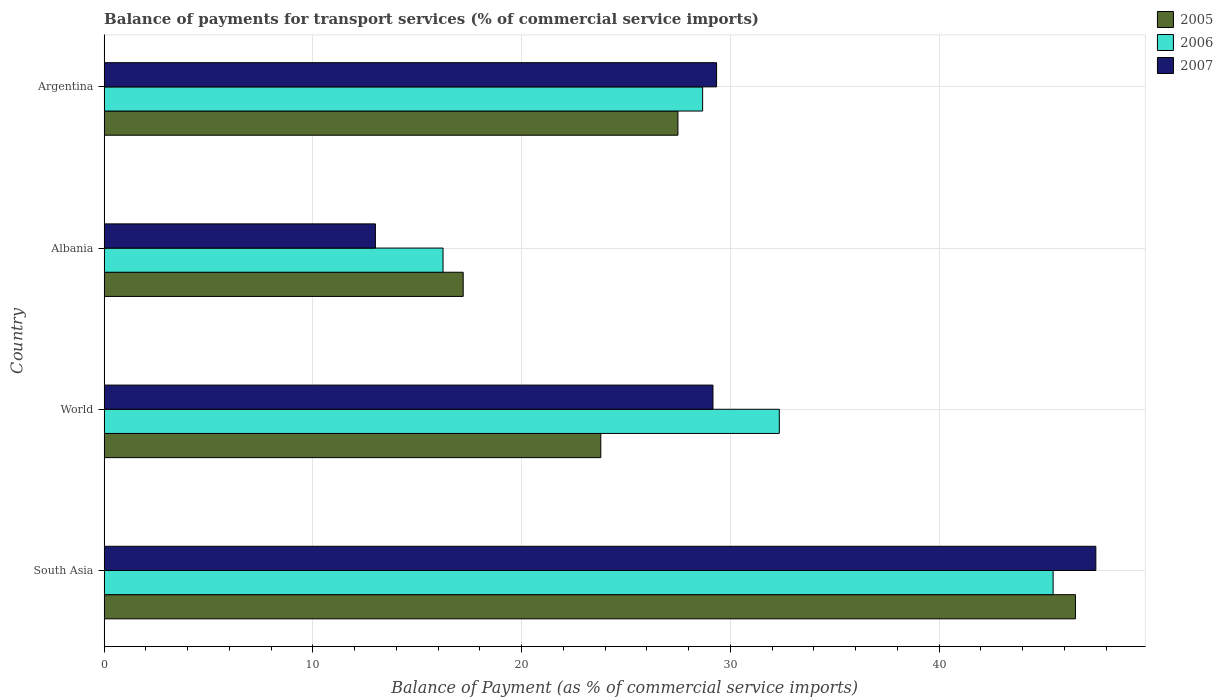How many groups of bars are there?
Your answer should be compact. 4. How many bars are there on the 1st tick from the top?
Offer a very short reply. 3. What is the balance of payments for transport services in 2007 in Argentina?
Offer a terse response. 29.34. Across all countries, what is the maximum balance of payments for transport services in 2007?
Make the answer very short. 47.5. Across all countries, what is the minimum balance of payments for transport services in 2005?
Your response must be concise. 17.2. In which country was the balance of payments for transport services in 2007 minimum?
Your answer should be very brief. Albania. What is the total balance of payments for transport services in 2007 in the graph?
Provide a succinct answer. 118.99. What is the difference between the balance of payments for transport services in 2007 in Argentina and that in World?
Offer a very short reply. 0.17. What is the difference between the balance of payments for transport services in 2006 in Argentina and the balance of payments for transport services in 2005 in World?
Your response must be concise. 4.88. What is the average balance of payments for transport services in 2006 per country?
Your answer should be compact. 30.67. What is the difference between the balance of payments for transport services in 2005 and balance of payments for transport services in 2006 in World?
Provide a succinct answer. -8.55. In how many countries, is the balance of payments for transport services in 2006 greater than 42 %?
Make the answer very short. 1. What is the ratio of the balance of payments for transport services in 2007 in Albania to that in World?
Your answer should be very brief. 0.45. Is the balance of payments for transport services in 2007 in Albania less than that in Argentina?
Make the answer very short. Yes. Is the difference between the balance of payments for transport services in 2005 in Albania and South Asia greater than the difference between the balance of payments for transport services in 2006 in Albania and South Asia?
Offer a terse response. No. What is the difference between the highest and the second highest balance of payments for transport services in 2007?
Ensure brevity in your answer.  18.17. What is the difference between the highest and the lowest balance of payments for transport services in 2006?
Your answer should be compact. 29.22. What does the 2nd bar from the top in World represents?
Offer a very short reply. 2006. Is it the case that in every country, the sum of the balance of payments for transport services in 2007 and balance of payments for transport services in 2005 is greater than the balance of payments for transport services in 2006?
Provide a short and direct response. Yes. How many countries are there in the graph?
Give a very brief answer. 4. Are the values on the major ticks of X-axis written in scientific E-notation?
Make the answer very short. No. Does the graph contain grids?
Provide a short and direct response. Yes. How many legend labels are there?
Offer a terse response. 3. How are the legend labels stacked?
Ensure brevity in your answer.  Vertical. What is the title of the graph?
Provide a succinct answer. Balance of payments for transport services (% of commercial service imports). What is the label or title of the X-axis?
Ensure brevity in your answer.  Balance of Payment (as % of commercial service imports). What is the label or title of the Y-axis?
Make the answer very short. Country. What is the Balance of Payment (as % of commercial service imports) of 2005 in South Asia?
Offer a terse response. 46.53. What is the Balance of Payment (as % of commercial service imports) of 2006 in South Asia?
Give a very brief answer. 45.46. What is the Balance of Payment (as % of commercial service imports) of 2007 in South Asia?
Give a very brief answer. 47.5. What is the Balance of Payment (as % of commercial service imports) of 2005 in World?
Ensure brevity in your answer.  23.79. What is the Balance of Payment (as % of commercial service imports) in 2006 in World?
Make the answer very short. 32.34. What is the Balance of Payment (as % of commercial service imports) in 2007 in World?
Offer a very short reply. 29.16. What is the Balance of Payment (as % of commercial service imports) of 2005 in Albania?
Your answer should be compact. 17.2. What is the Balance of Payment (as % of commercial service imports) of 2006 in Albania?
Make the answer very short. 16.23. What is the Balance of Payment (as % of commercial service imports) in 2007 in Albania?
Ensure brevity in your answer.  12.99. What is the Balance of Payment (as % of commercial service imports) in 2005 in Argentina?
Offer a terse response. 27.48. What is the Balance of Payment (as % of commercial service imports) in 2006 in Argentina?
Provide a succinct answer. 28.67. What is the Balance of Payment (as % of commercial service imports) of 2007 in Argentina?
Provide a short and direct response. 29.34. Across all countries, what is the maximum Balance of Payment (as % of commercial service imports) in 2005?
Keep it short and to the point. 46.53. Across all countries, what is the maximum Balance of Payment (as % of commercial service imports) of 2006?
Ensure brevity in your answer.  45.46. Across all countries, what is the maximum Balance of Payment (as % of commercial service imports) of 2007?
Keep it short and to the point. 47.5. Across all countries, what is the minimum Balance of Payment (as % of commercial service imports) in 2005?
Your answer should be very brief. 17.2. Across all countries, what is the minimum Balance of Payment (as % of commercial service imports) in 2006?
Provide a succinct answer. 16.23. Across all countries, what is the minimum Balance of Payment (as % of commercial service imports) of 2007?
Keep it short and to the point. 12.99. What is the total Balance of Payment (as % of commercial service imports) of 2005 in the graph?
Your answer should be compact. 115. What is the total Balance of Payment (as % of commercial service imports) of 2006 in the graph?
Ensure brevity in your answer.  122.69. What is the total Balance of Payment (as % of commercial service imports) in 2007 in the graph?
Offer a terse response. 118.99. What is the difference between the Balance of Payment (as % of commercial service imports) in 2005 in South Asia and that in World?
Your answer should be compact. 22.74. What is the difference between the Balance of Payment (as % of commercial service imports) of 2006 in South Asia and that in World?
Offer a terse response. 13.12. What is the difference between the Balance of Payment (as % of commercial service imports) in 2007 in South Asia and that in World?
Provide a succinct answer. 18.34. What is the difference between the Balance of Payment (as % of commercial service imports) of 2005 in South Asia and that in Albania?
Offer a terse response. 29.33. What is the difference between the Balance of Payment (as % of commercial service imports) in 2006 in South Asia and that in Albania?
Offer a very short reply. 29.22. What is the difference between the Balance of Payment (as % of commercial service imports) in 2007 in South Asia and that in Albania?
Offer a very short reply. 34.51. What is the difference between the Balance of Payment (as % of commercial service imports) in 2005 in South Asia and that in Argentina?
Provide a succinct answer. 19.04. What is the difference between the Balance of Payment (as % of commercial service imports) in 2006 in South Asia and that in Argentina?
Offer a terse response. 16.79. What is the difference between the Balance of Payment (as % of commercial service imports) of 2007 in South Asia and that in Argentina?
Your response must be concise. 18.17. What is the difference between the Balance of Payment (as % of commercial service imports) in 2005 in World and that in Albania?
Provide a short and direct response. 6.59. What is the difference between the Balance of Payment (as % of commercial service imports) in 2006 in World and that in Albania?
Your answer should be compact. 16.11. What is the difference between the Balance of Payment (as % of commercial service imports) of 2007 in World and that in Albania?
Your answer should be very brief. 16.17. What is the difference between the Balance of Payment (as % of commercial service imports) in 2005 in World and that in Argentina?
Your answer should be very brief. -3.69. What is the difference between the Balance of Payment (as % of commercial service imports) in 2006 in World and that in Argentina?
Offer a terse response. 3.67. What is the difference between the Balance of Payment (as % of commercial service imports) in 2007 in World and that in Argentina?
Keep it short and to the point. -0.17. What is the difference between the Balance of Payment (as % of commercial service imports) of 2005 in Albania and that in Argentina?
Make the answer very short. -10.29. What is the difference between the Balance of Payment (as % of commercial service imports) in 2006 in Albania and that in Argentina?
Provide a short and direct response. -12.43. What is the difference between the Balance of Payment (as % of commercial service imports) of 2007 in Albania and that in Argentina?
Give a very brief answer. -16.34. What is the difference between the Balance of Payment (as % of commercial service imports) of 2005 in South Asia and the Balance of Payment (as % of commercial service imports) of 2006 in World?
Ensure brevity in your answer.  14.19. What is the difference between the Balance of Payment (as % of commercial service imports) of 2005 in South Asia and the Balance of Payment (as % of commercial service imports) of 2007 in World?
Ensure brevity in your answer.  17.36. What is the difference between the Balance of Payment (as % of commercial service imports) of 2006 in South Asia and the Balance of Payment (as % of commercial service imports) of 2007 in World?
Give a very brief answer. 16.29. What is the difference between the Balance of Payment (as % of commercial service imports) of 2005 in South Asia and the Balance of Payment (as % of commercial service imports) of 2006 in Albania?
Keep it short and to the point. 30.29. What is the difference between the Balance of Payment (as % of commercial service imports) of 2005 in South Asia and the Balance of Payment (as % of commercial service imports) of 2007 in Albania?
Provide a short and direct response. 33.53. What is the difference between the Balance of Payment (as % of commercial service imports) of 2006 in South Asia and the Balance of Payment (as % of commercial service imports) of 2007 in Albania?
Offer a very short reply. 32.46. What is the difference between the Balance of Payment (as % of commercial service imports) in 2005 in South Asia and the Balance of Payment (as % of commercial service imports) in 2006 in Argentina?
Offer a very short reply. 17.86. What is the difference between the Balance of Payment (as % of commercial service imports) in 2005 in South Asia and the Balance of Payment (as % of commercial service imports) in 2007 in Argentina?
Ensure brevity in your answer.  17.19. What is the difference between the Balance of Payment (as % of commercial service imports) in 2006 in South Asia and the Balance of Payment (as % of commercial service imports) in 2007 in Argentina?
Provide a succinct answer. 16.12. What is the difference between the Balance of Payment (as % of commercial service imports) of 2005 in World and the Balance of Payment (as % of commercial service imports) of 2006 in Albania?
Your answer should be very brief. 7.56. What is the difference between the Balance of Payment (as % of commercial service imports) in 2005 in World and the Balance of Payment (as % of commercial service imports) in 2007 in Albania?
Provide a short and direct response. 10.8. What is the difference between the Balance of Payment (as % of commercial service imports) in 2006 in World and the Balance of Payment (as % of commercial service imports) in 2007 in Albania?
Provide a short and direct response. 19.35. What is the difference between the Balance of Payment (as % of commercial service imports) in 2005 in World and the Balance of Payment (as % of commercial service imports) in 2006 in Argentina?
Provide a short and direct response. -4.88. What is the difference between the Balance of Payment (as % of commercial service imports) of 2005 in World and the Balance of Payment (as % of commercial service imports) of 2007 in Argentina?
Provide a short and direct response. -5.55. What is the difference between the Balance of Payment (as % of commercial service imports) of 2006 in World and the Balance of Payment (as % of commercial service imports) of 2007 in Argentina?
Your response must be concise. 3. What is the difference between the Balance of Payment (as % of commercial service imports) in 2005 in Albania and the Balance of Payment (as % of commercial service imports) in 2006 in Argentina?
Keep it short and to the point. -11.47. What is the difference between the Balance of Payment (as % of commercial service imports) in 2005 in Albania and the Balance of Payment (as % of commercial service imports) in 2007 in Argentina?
Your answer should be very brief. -12.14. What is the difference between the Balance of Payment (as % of commercial service imports) of 2006 in Albania and the Balance of Payment (as % of commercial service imports) of 2007 in Argentina?
Offer a terse response. -13.1. What is the average Balance of Payment (as % of commercial service imports) in 2005 per country?
Make the answer very short. 28.75. What is the average Balance of Payment (as % of commercial service imports) in 2006 per country?
Your answer should be very brief. 30.67. What is the average Balance of Payment (as % of commercial service imports) of 2007 per country?
Offer a very short reply. 29.75. What is the difference between the Balance of Payment (as % of commercial service imports) of 2005 and Balance of Payment (as % of commercial service imports) of 2006 in South Asia?
Your response must be concise. 1.07. What is the difference between the Balance of Payment (as % of commercial service imports) in 2005 and Balance of Payment (as % of commercial service imports) in 2007 in South Asia?
Offer a very short reply. -0.98. What is the difference between the Balance of Payment (as % of commercial service imports) of 2006 and Balance of Payment (as % of commercial service imports) of 2007 in South Asia?
Your answer should be very brief. -2.05. What is the difference between the Balance of Payment (as % of commercial service imports) of 2005 and Balance of Payment (as % of commercial service imports) of 2006 in World?
Keep it short and to the point. -8.55. What is the difference between the Balance of Payment (as % of commercial service imports) in 2005 and Balance of Payment (as % of commercial service imports) in 2007 in World?
Offer a very short reply. -5.37. What is the difference between the Balance of Payment (as % of commercial service imports) of 2006 and Balance of Payment (as % of commercial service imports) of 2007 in World?
Provide a short and direct response. 3.18. What is the difference between the Balance of Payment (as % of commercial service imports) in 2005 and Balance of Payment (as % of commercial service imports) in 2006 in Albania?
Your answer should be compact. 0.97. What is the difference between the Balance of Payment (as % of commercial service imports) of 2005 and Balance of Payment (as % of commercial service imports) of 2007 in Albania?
Your answer should be compact. 4.2. What is the difference between the Balance of Payment (as % of commercial service imports) of 2006 and Balance of Payment (as % of commercial service imports) of 2007 in Albania?
Offer a terse response. 3.24. What is the difference between the Balance of Payment (as % of commercial service imports) in 2005 and Balance of Payment (as % of commercial service imports) in 2006 in Argentina?
Offer a terse response. -1.18. What is the difference between the Balance of Payment (as % of commercial service imports) of 2005 and Balance of Payment (as % of commercial service imports) of 2007 in Argentina?
Make the answer very short. -1.85. What is the difference between the Balance of Payment (as % of commercial service imports) of 2006 and Balance of Payment (as % of commercial service imports) of 2007 in Argentina?
Make the answer very short. -0.67. What is the ratio of the Balance of Payment (as % of commercial service imports) in 2005 in South Asia to that in World?
Provide a succinct answer. 1.96. What is the ratio of the Balance of Payment (as % of commercial service imports) in 2006 in South Asia to that in World?
Your response must be concise. 1.41. What is the ratio of the Balance of Payment (as % of commercial service imports) in 2007 in South Asia to that in World?
Make the answer very short. 1.63. What is the ratio of the Balance of Payment (as % of commercial service imports) of 2005 in South Asia to that in Albania?
Make the answer very short. 2.71. What is the ratio of the Balance of Payment (as % of commercial service imports) in 2006 in South Asia to that in Albania?
Provide a short and direct response. 2.8. What is the ratio of the Balance of Payment (as % of commercial service imports) of 2007 in South Asia to that in Albania?
Your response must be concise. 3.66. What is the ratio of the Balance of Payment (as % of commercial service imports) of 2005 in South Asia to that in Argentina?
Keep it short and to the point. 1.69. What is the ratio of the Balance of Payment (as % of commercial service imports) of 2006 in South Asia to that in Argentina?
Your response must be concise. 1.59. What is the ratio of the Balance of Payment (as % of commercial service imports) of 2007 in South Asia to that in Argentina?
Provide a short and direct response. 1.62. What is the ratio of the Balance of Payment (as % of commercial service imports) in 2005 in World to that in Albania?
Offer a very short reply. 1.38. What is the ratio of the Balance of Payment (as % of commercial service imports) in 2006 in World to that in Albania?
Your answer should be compact. 1.99. What is the ratio of the Balance of Payment (as % of commercial service imports) in 2007 in World to that in Albania?
Make the answer very short. 2.24. What is the ratio of the Balance of Payment (as % of commercial service imports) of 2005 in World to that in Argentina?
Provide a short and direct response. 0.87. What is the ratio of the Balance of Payment (as % of commercial service imports) of 2006 in World to that in Argentina?
Keep it short and to the point. 1.13. What is the ratio of the Balance of Payment (as % of commercial service imports) of 2007 in World to that in Argentina?
Give a very brief answer. 0.99. What is the ratio of the Balance of Payment (as % of commercial service imports) of 2005 in Albania to that in Argentina?
Your answer should be compact. 0.63. What is the ratio of the Balance of Payment (as % of commercial service imports) of 2006 in Albania to that in Argentina?
Make the answer very short. 0.57. What is the ratio of the Balance of Payment (as % of commercial service imports) of 2007 in Albania to that in Argentina?
Make the answer very short. 0.44. What is the difference between the highest and the second highest Balance of Payment (as % of commercial service imports) of 2005?
Keep it short and to the point. 19.04. What is the difference between the highest and the second highest Balance of Payment (as % of commercial service imports) in 2006?
Make the answer very short. 13.12. What is the difference between the highest and the second highest Balance of Payment (as % of commercial service imports) of 2007?
Make the answer very short. 18.17. What is the difference between the highest and the lowest Balance of Payment (as % of commercial service imports) of 2005?
Make the answer very short. 29.33. What is the difference between the highest and the lowest Balance of Payment (as % of commercial service imports) of 2006?
Ensure brevity in your answer.  29.22. What is the difference between the highest and the lowest Balance of Payment (as % of commercial service imports) of 2007?
Give a very brief answer. 34.51. 